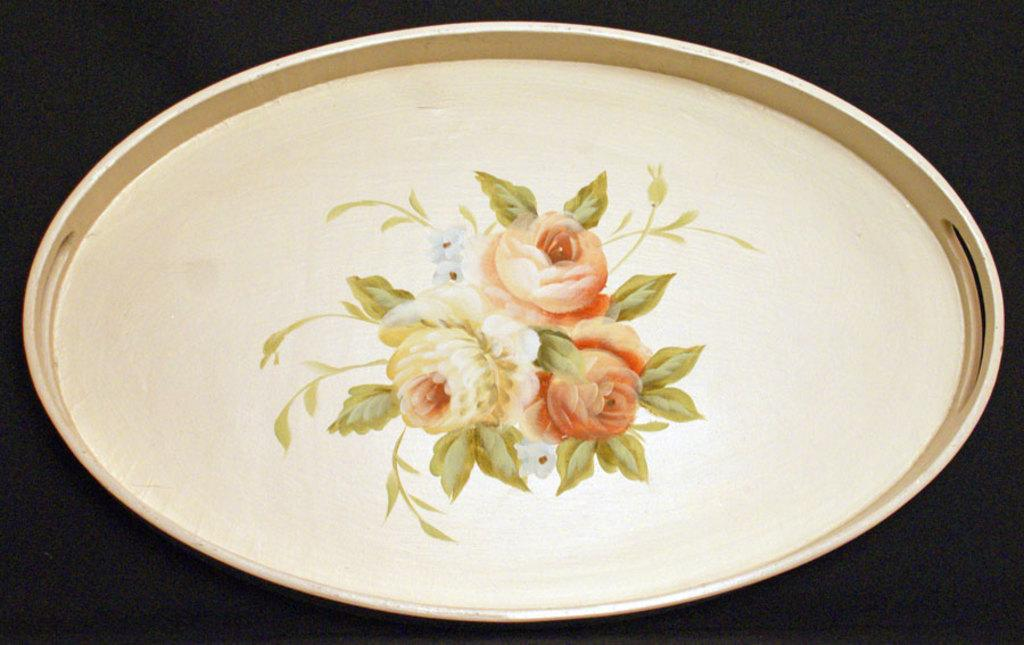What object is present in the image that can hold other items? There is a tray in the image that can hold other items. What can be observed about the appearance of the tray? The tray has a design on it. What can be said about the overall lighting or color scheme of the image? The background of the image is dark. What type of polish is being applied to the honey in the image? There is no polish or honey present in the image; it only features a tray with a design. 